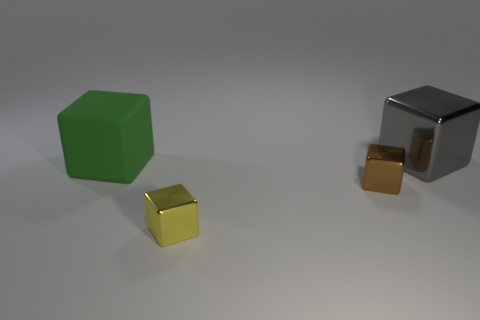Add 4 large green metal things. How many objects exist? 8 Subtract all brown metal cubes. How many cubes are left? 3 Subtract all brown cubes. How many cubes are left? 3 Subtract 3 cubes. How many cubes are left? 1 Subtract all tiny red metallic objects. Subtract all large gray metal blocks. How many objects are left? 3 Add 2 gray shiny cubes. How many gray shiny cubes are left? 3 Add 1 tiny brown blocks. How many tiny brown blocks exist? 2 Subtract 0 green balls. How many objects are left? 4 Subtract all purple cubes. Subtract all blue balls. How many cubes are left? 4 